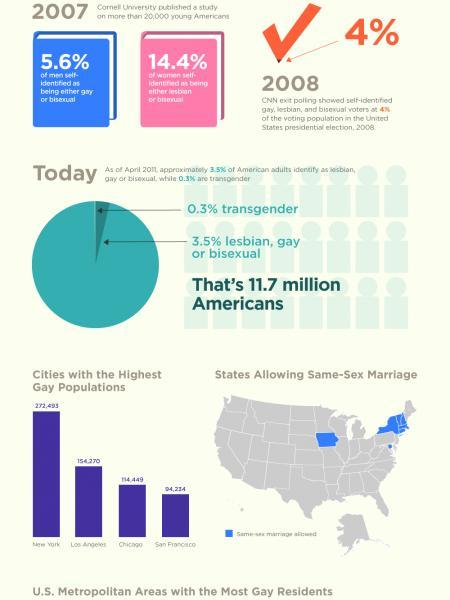Which city in the US has the third highest number of gay people?
Answer the question with a short phrase. Chicago In which year was the percentage of lesbian or bisexual women at 14.4%? 2007 